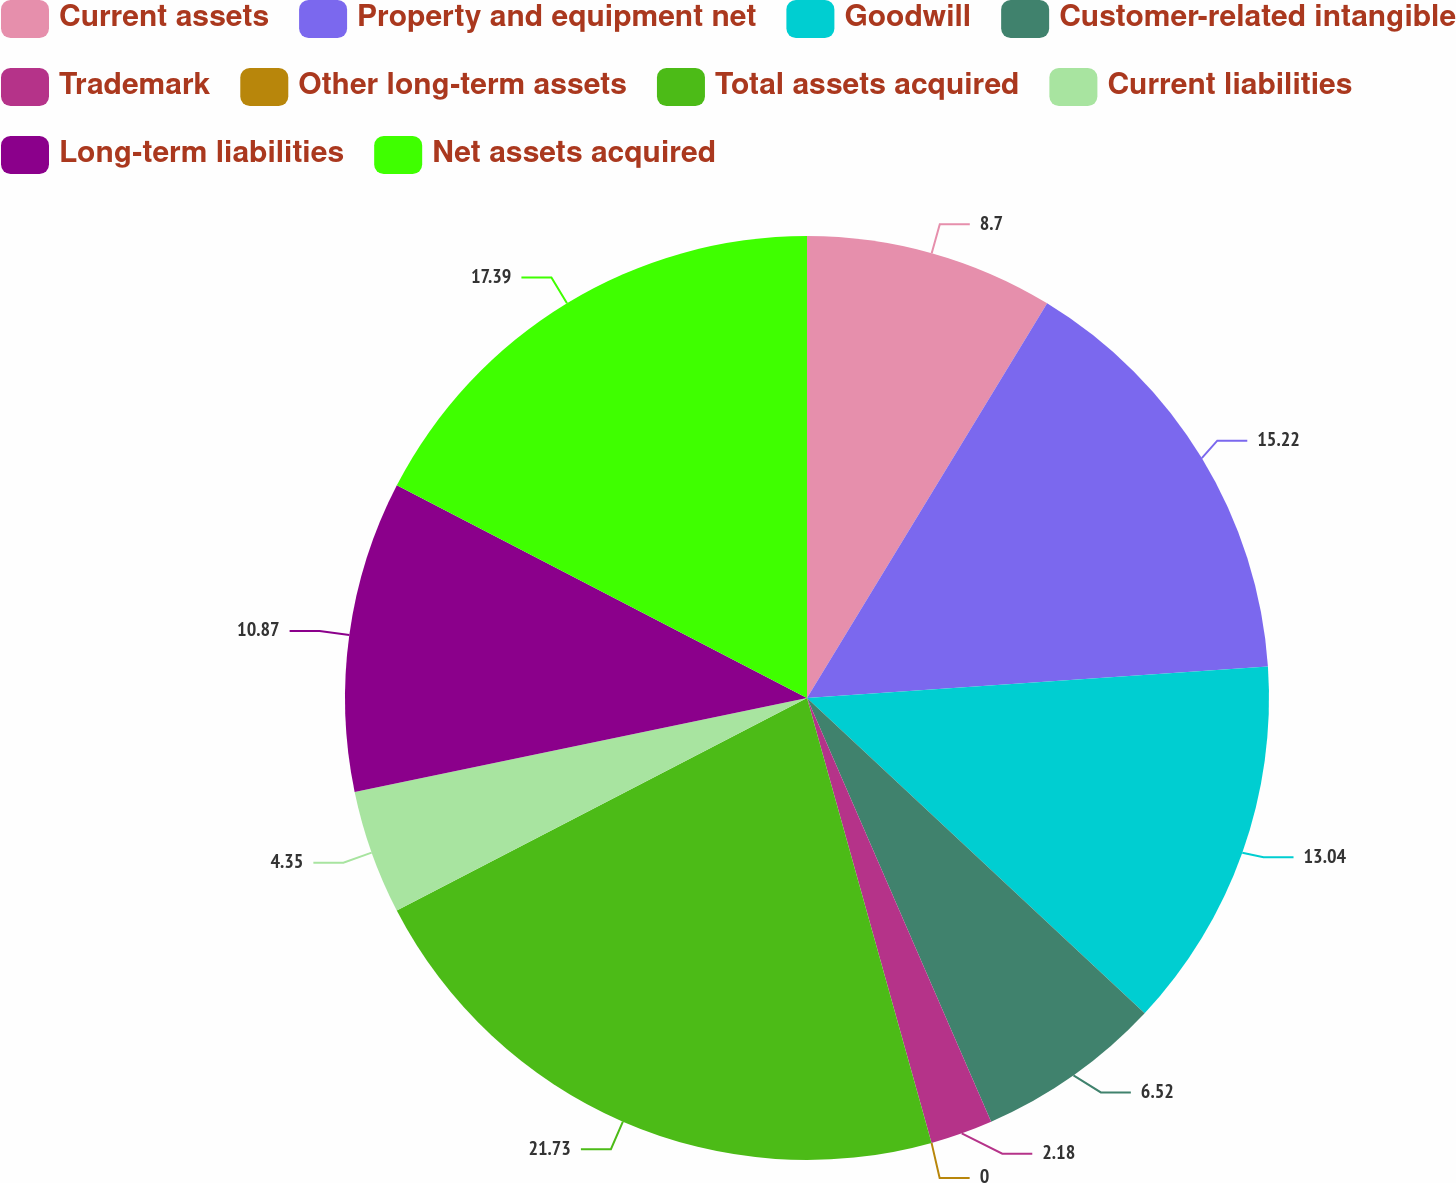Convert chart to OTSL. <chart><loc_0><loc_0><loc_500><loc_500><pie_chart><fcel>Current assets<fcel>Property and equipment net<fcel>Goodwill<fcel>Customer-related intangible<fcel>Trademark<fcel>Other long-term assets<fcel>Total assets acquired<fcel>Current liabilities<fcel>Long-term liabilities<fcel>Net assets acquired<nl><fcel>8.7%<fcel>15.22%<fcel>13.04%<fcel>6.52%<fcel>2.18%<fcel>0.0%<fcel>21.74%<fcel>4.35%<fcel>10.87%<fcel>17.39%<nl></chart> 